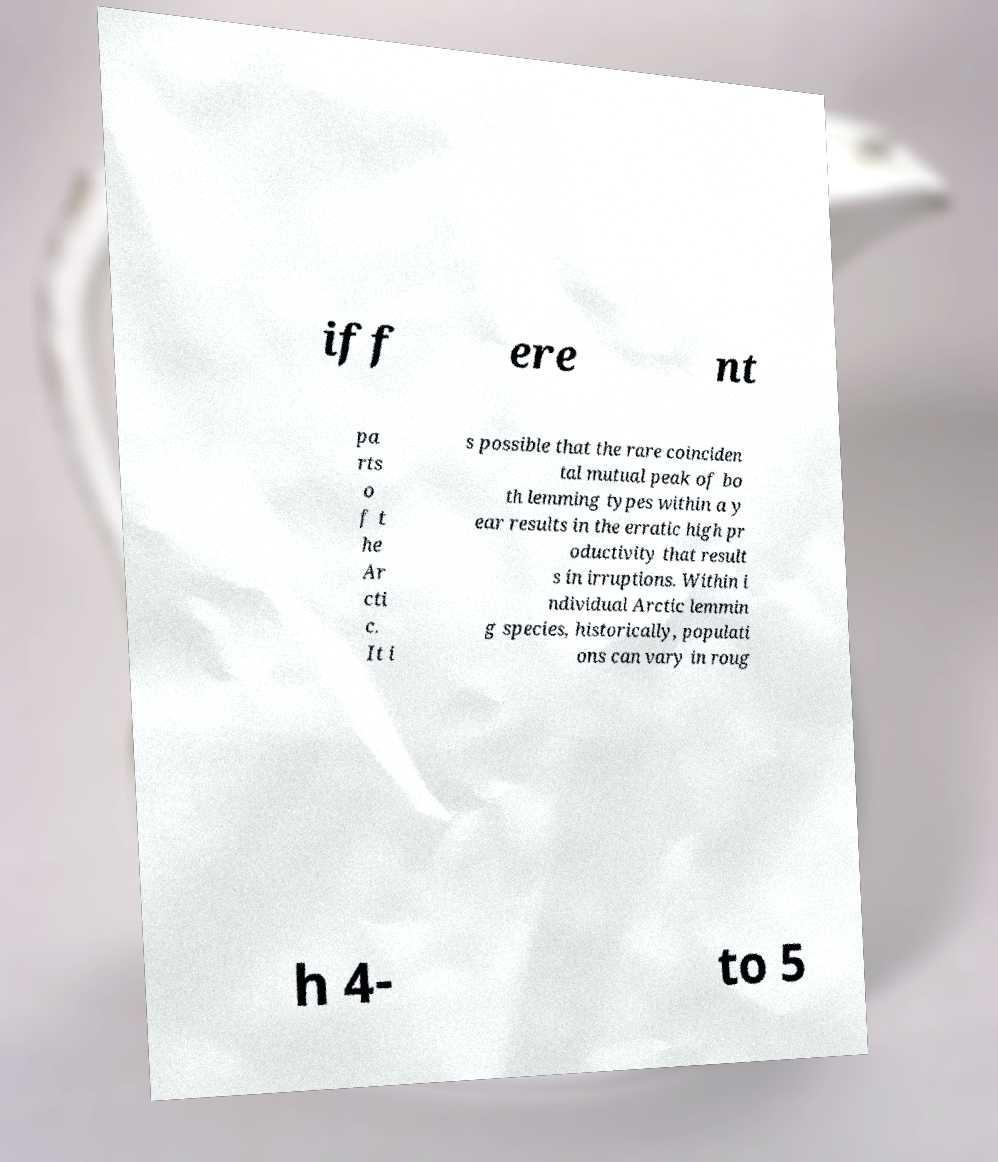Can you read and provide the text displayed in the image?This photo seems to have some interesting text. Can you extract and type it out for me? iff ere nt pa rts o f t he Ar cti c. It i s possible that the rare coinciden tal mutual peak of bo th lemming types within a y ear results in the erratic high pr oductivity that result s in irruptions. Within i ndividual Arctic lemmin g species, historically, populati ons can vary in roug h 4- to 5 